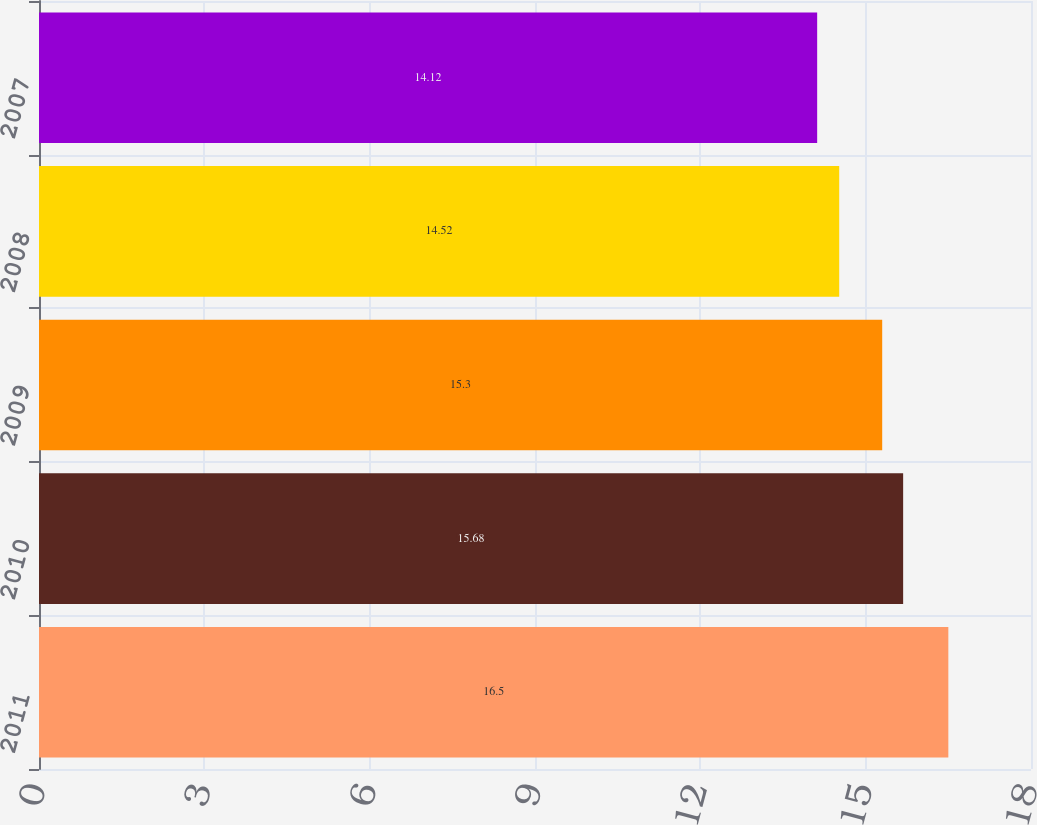Convert chart. <chart><loc_0><loc_0><loc_500><loc_500><bar_chart><fcel>2011<fcel>2010<fcel>2009<fcel>2008<fcel>2007<nl><fcel>16.5<fcel>15.68<fcel>15.3<fcel>14.52<fcel>14.12<nl></chart> 